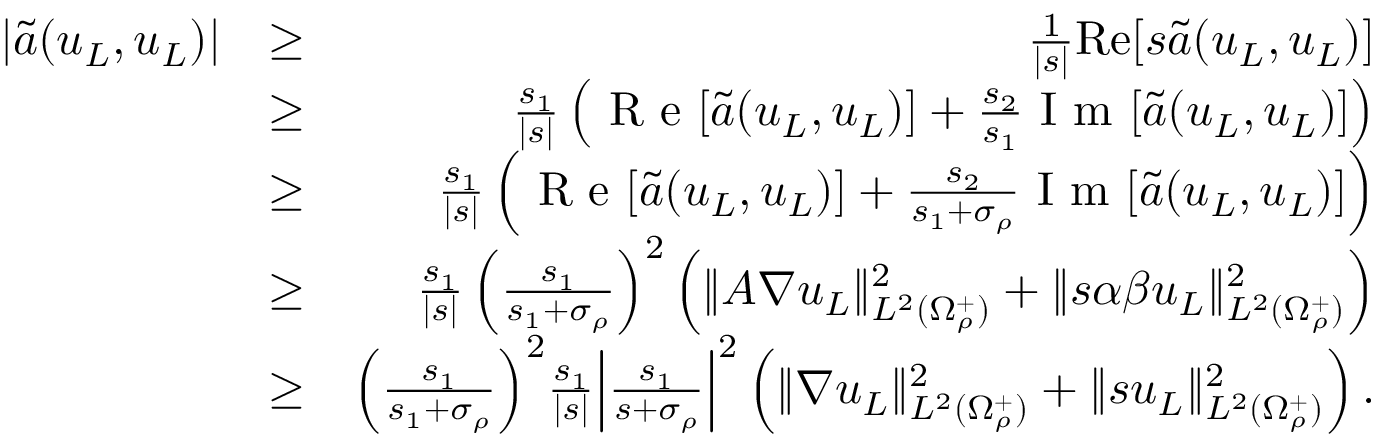Convert formula to latex. <formula><loc_0><loc_0><loc_500><loc_500>\begin{array} { r l r } { | \tilde { a } ( u _ { L } , u _ { L } ) | } & { \geq } & { \frac { 1 } { | s | } R e [ s \tilde { a } ( u _ { L } , u _ { L } ) ] } \\ & { \geq } & { \frac { s _ { 1 } } { | s | } \left ( R e [ \tilde { a } ( u _ { L } , u _ { L } ) ] + \frac { s _ { 2 } } { s _ { 1 } } I m [ \tilde { a } ( u _ { L } , u _ { L } ) ] \right ) } \\ & { \geq } & { \frac { s _ { 1 } } { | s | } \left ( R e [ \tilde { a } ( u _ { L } , u _ { L } ) ] + \frac { s _ { 2 } } { s _ { 1 } + \sigma _ { \rho } } I m [ \tilde { a } ( u _ { L } , u _ { L } ) ] \right ) } \\ & { \geq } & { \frac { s _ { 1 } } { | s | } \left ( \frac { s _ { 1 } } { s _ { 1 } + \sigma _ { \rho } } \right ) ^ { 2 } \left ( \| A \nabla u _ { L } \| _ { L ^ { 2 } ( \Omega _ { \rho } ^ { + } ) } ^ { 2 } + \| s \alpha \beta u _ { L } \| _ { L ^ { 2 } ( \Omega _ { \rho } ^ { + } ) } ^ { 2 } \right ) } \\ & { \geq } & { \left ( \frac { s _ { 1 } } { s _ { 1 } + \sigma _ { \rho } } \right ) ^ { 2 } \frac { s _ { 1 } } { | s | } \left | \frac { s _ { 1 } } { s + \sigma _ { \rho } } \right | ^ { 2 } \left ( \| \nabla u _ { L } \| _ { L ^ { 2 } ( \Omega _ { \rho } ^ { + } ) } ^ { 2 } + \| s u _ { L } \| _ { L ^ { 2 } ( \Omega _ { \rho } ^ { + } ) } ^ { 2 } \right ) . } \end{array}</formula> 